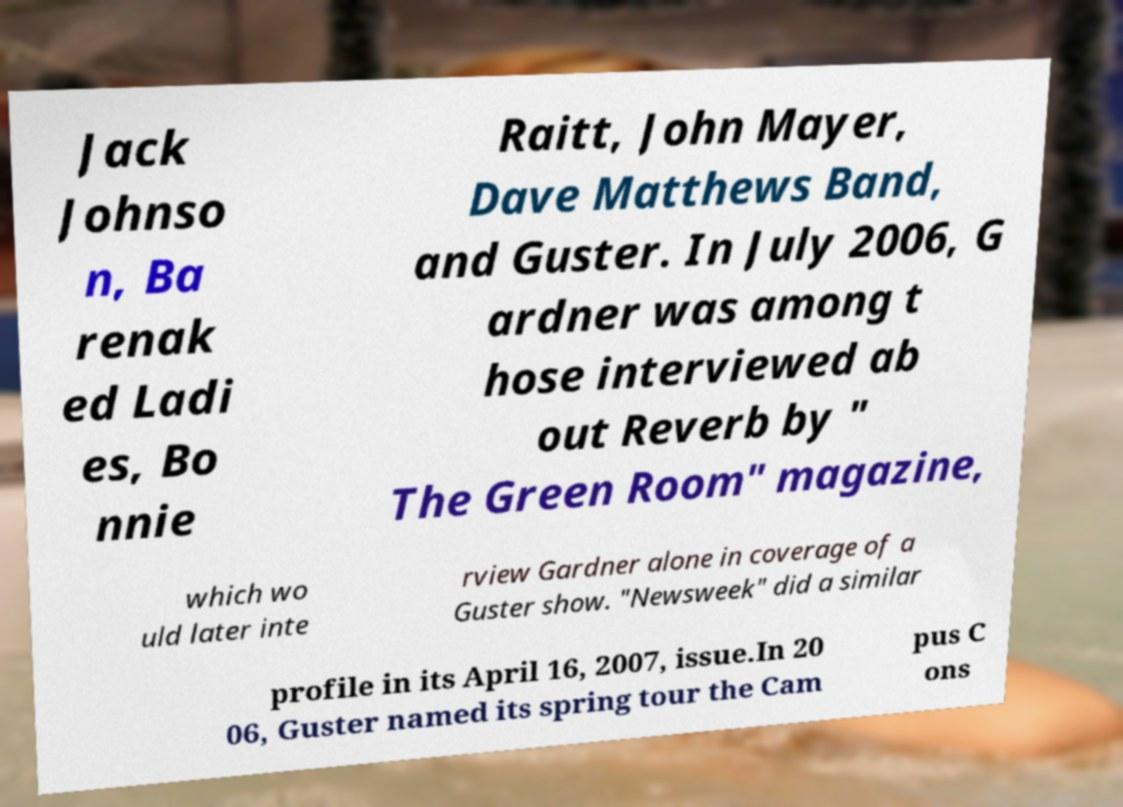There's text embedded in this image that I need extracted. Can you transcribe it verbatim? Jack Johnso n, Ba renak ed Ladi es, Bo nnie Raitt, John Mayer, Dave Matthews Band, and Guster. In July 2006, G ardner was among t hose interviewed ab out Reverb by " The Green Room" magazine, which wo uld later inte rview Gardner alone in coverage of a Guster show. "Newsweek" did a similar profile in its April 16, 2007, issue.In 20 06, Guster named its spring tour the Cam pus C ons 